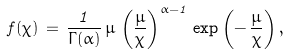<formula> <loc_0><loc_0><loc_500><loc_500>f ( \chi ) \, = \, \frac { 1 } { \Gamma ( \alpha ) } \, \mu \, \left ( \frac { \mu } { \chi } \right ) ^ { \alpha - 1 } \, \exp \left ( - \, \frac { \mu } { \chi } \right ) ,</formula> 